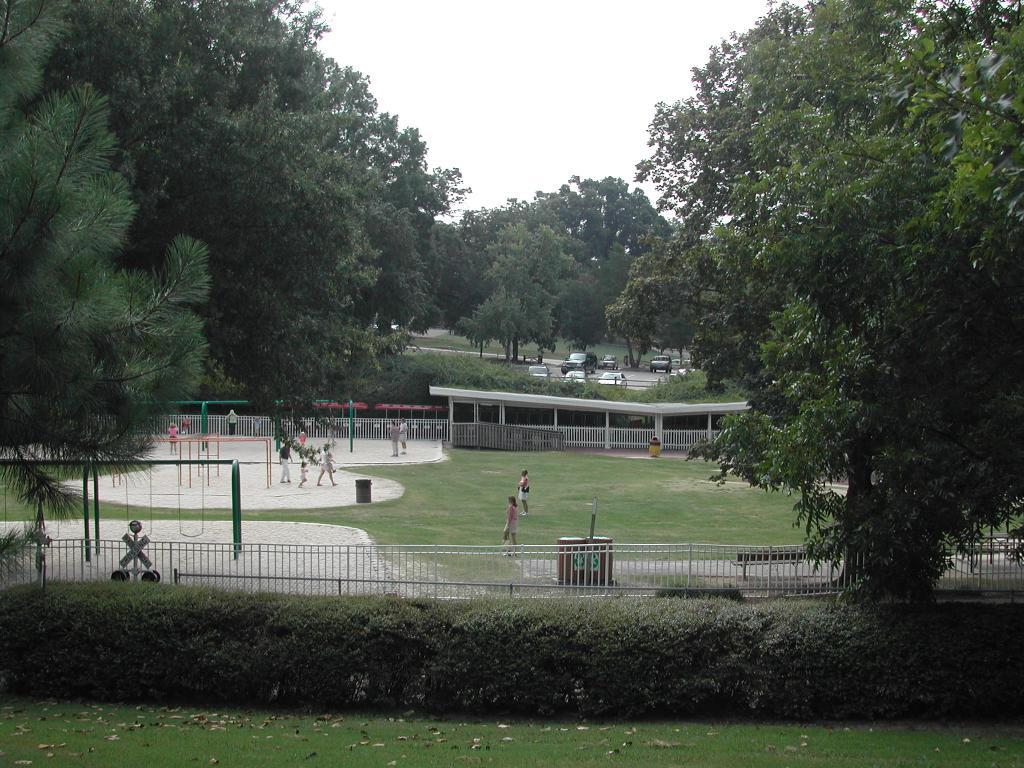What type of vegetation can be seen in the image? There are many trees and plants visible in the image. What can be seen near the trees in the image? Railings are present in the image. What type of ground surface is visible in the image? Grass is visible in the image. What is in the middle of the image? There are people, roads, and vehicles visible in the middle of the image. What is visible at the top of the image? The sky is visible at the top of the image. What suggestion does the aunt make in the image? There is no aunt present in the image, and therefore no suggestion can be made. What color is the sky in the image? The color of the sky is not mentioned in the provided facts, so we cannot determine its color from the image. 